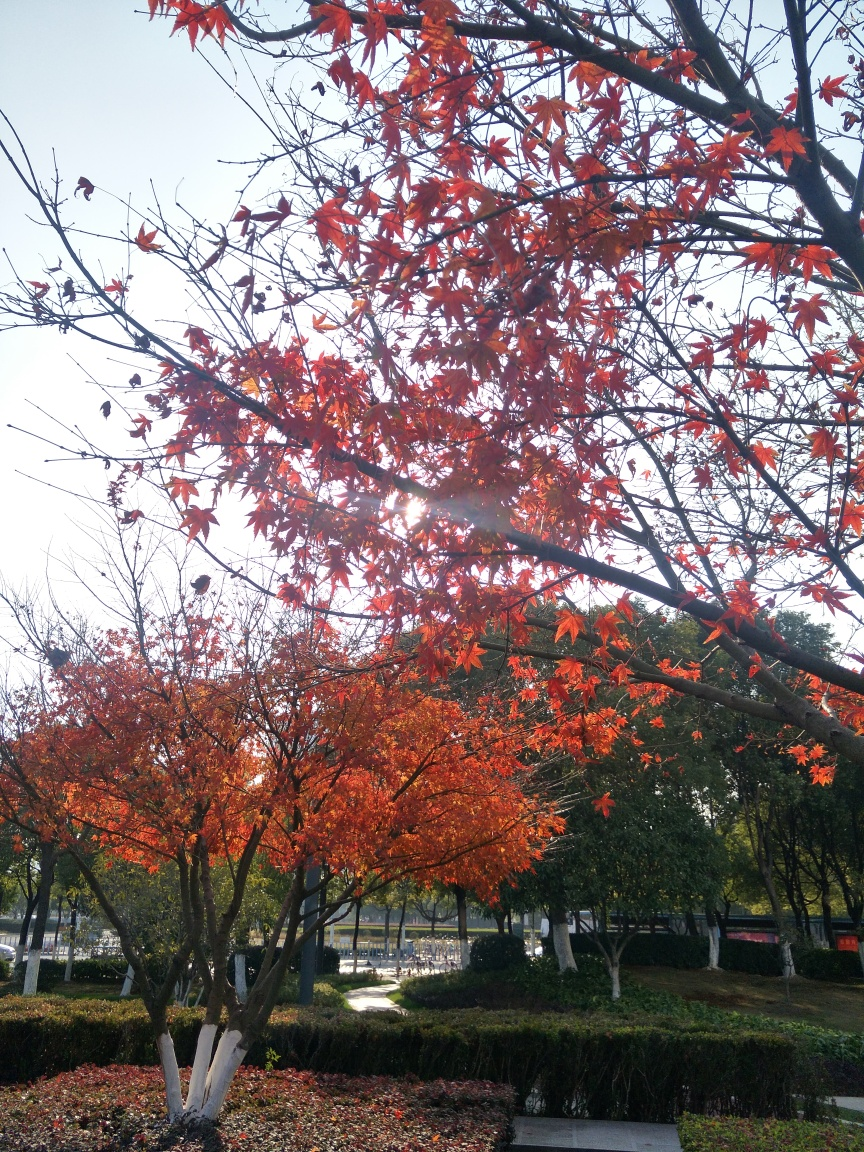Could you infer the climate of the region from the image? The presence of deciduous trees with leaves changing color signifies a temperate climate zone that experiences distinct seasons, including a fall season where such foliage changes are common. 